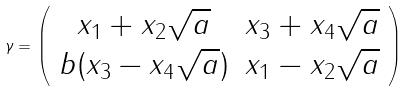<formula> <loc_0><loc_0><loc_500><loc_500>\gamma = \left ( \begin{array} { c c } x _ { 1 } + x _ { 2 } \sqrt { a } & x _ { 3 } + x _ { 4 } \sqrt { a } \\ b ( x _ { 3 } - x _ { 4 } \sqrt { a } ) & x _ { 1 } - x _ { 2 } \sqrt { a } \end{array} \right )</formula> 